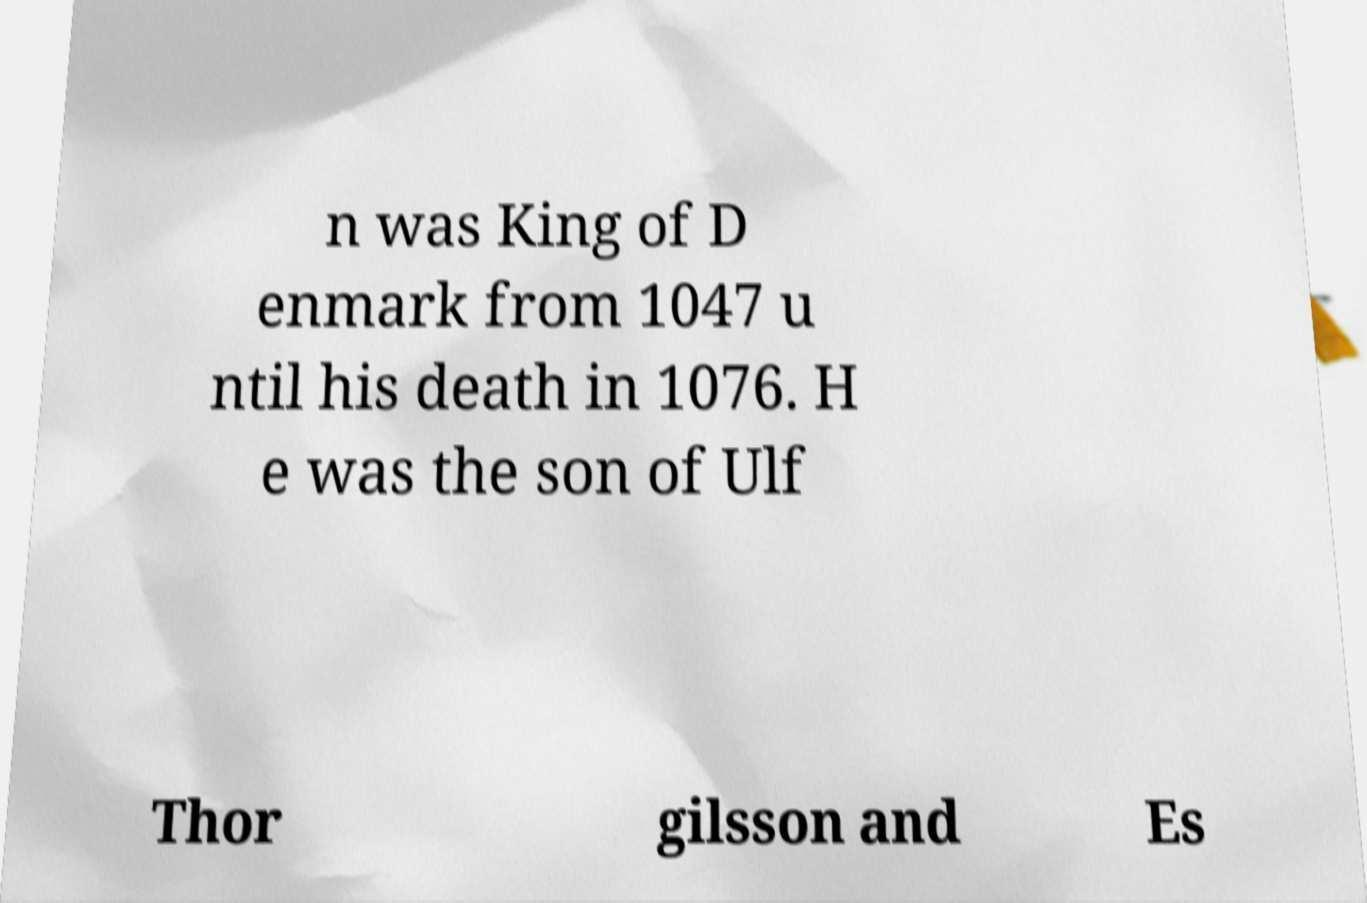For documentation purposes, I need the text within this image transcribed. Could you provide that? n was King of D enmark from 1047 u ntil his death in 1076. H e was the son of Ulf Thor gilsson and Es 